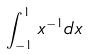<formula> <loc_0><loc_0><loc_500><loc_500>\int _ { - 1 } ^ { 1 } x ^ { - 1 } d x</formula> 